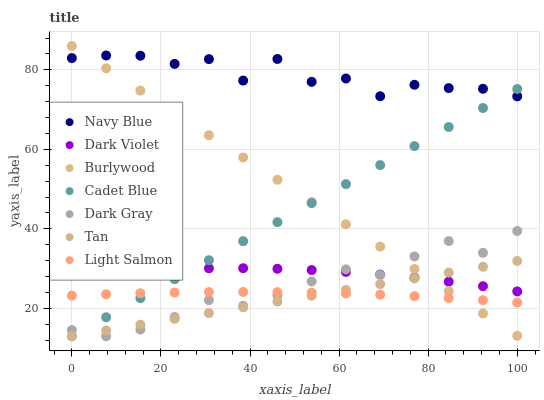Does Tan have the minimum area under the curve?
Answer yes or no. Yes. Does Navy Blue have the maximum area under the curve?
Answer yes or no. Yes. Does Cadet Blue have the minimum area under the curve?
Answer yes or no. No. Does Cadet Blue have the maximum area under the curve?
Answer yes or no. No. Is Tan the smoothest?
Answer yes or no. Yes. Is Navy Blue the roughest?
Answer yes or no. Yes. Is Cadet Blue the smoothest?
Answer yes or no. No. Is Cadet Blue the roughest?
Answer yes or no. No. Does Cadet Blue have the lowest value?
Answer yes or no. Yes. Does Burlywood have the lowest value?
Answer yes or no. No. Does Burlywood have the highest value?
Answer yes or no. Yes. Does Cadet Blue have the highest value?
Answer yes or no. No. Is Tan less than Navy Blue?
Answer yes or no. Yes. Is Navy Blue greater than Dark Gray?
Answer yes or no. Yes. Does Tan intersect Dark Gray?
Answer yes or no. Yes. Is Tan less than Dark Gray?
Answer yes or no. No. Is Tan greater than Dark Gray?
Answer yes or no. No. Does Tan intersect Navy Blue?
Answer yes or no. No. 